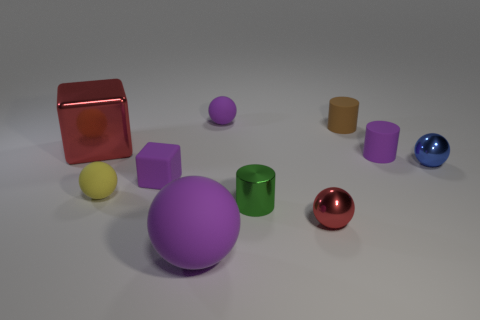How many objects are made of the same material as the small cube?
Keep it short and to the point. 5. Does the large red object have the same shape as the red metal object right of the large purple ball?
Make the answer very short. No. There is a cube that is left of the small ball on the left side of the big purple ball; is there a big sphere that is behind it?
Make the answer very short. No. How big is the purple rubber sphere behind the blue object?
Your response must be concise. Small. There is a purple cylinder that is the same size as the brown matte object; what is its material?
Offer a terse response. Rubber. Is the big purple matte object the same shape as the tiny brown matte object?
Your response must be concise. No. What number of objects are big red objects or red metallic things that are behind the tiny yellow matte sphere?
Your answer should be compact. 1. What material is the tiny sphere that is the same color as the matte cube?
Give a very brief answer. Rubber. There is a purple ball that is in front of the red shiny sphere; is its size the same as the red metallic cube?
Make the answer very short. Yes. There is a tiny cylinder in front of the metal sphere that is behind the tiny red metal sphere; what number of cylinders are in front of it?
Give a very brief answer. 0. 